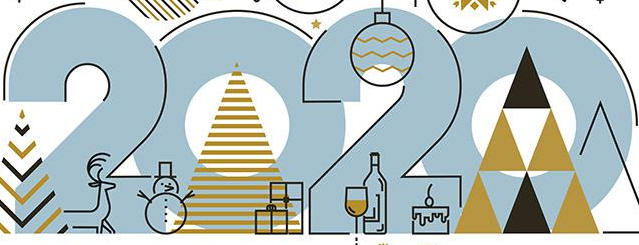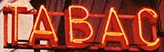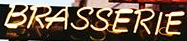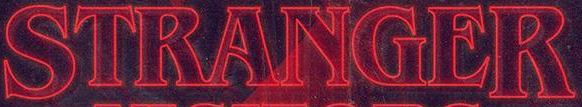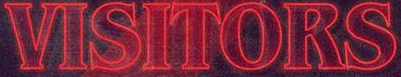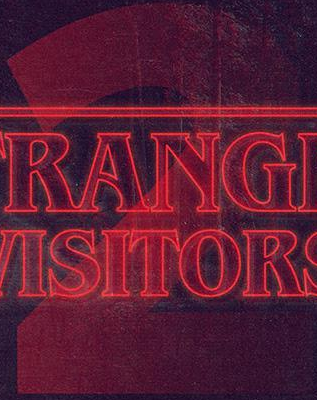What words are shown in these images in order, separated by a semicolon? 2020; TABAC; BRASSERIE; STRANGER; VISITORS; 2 